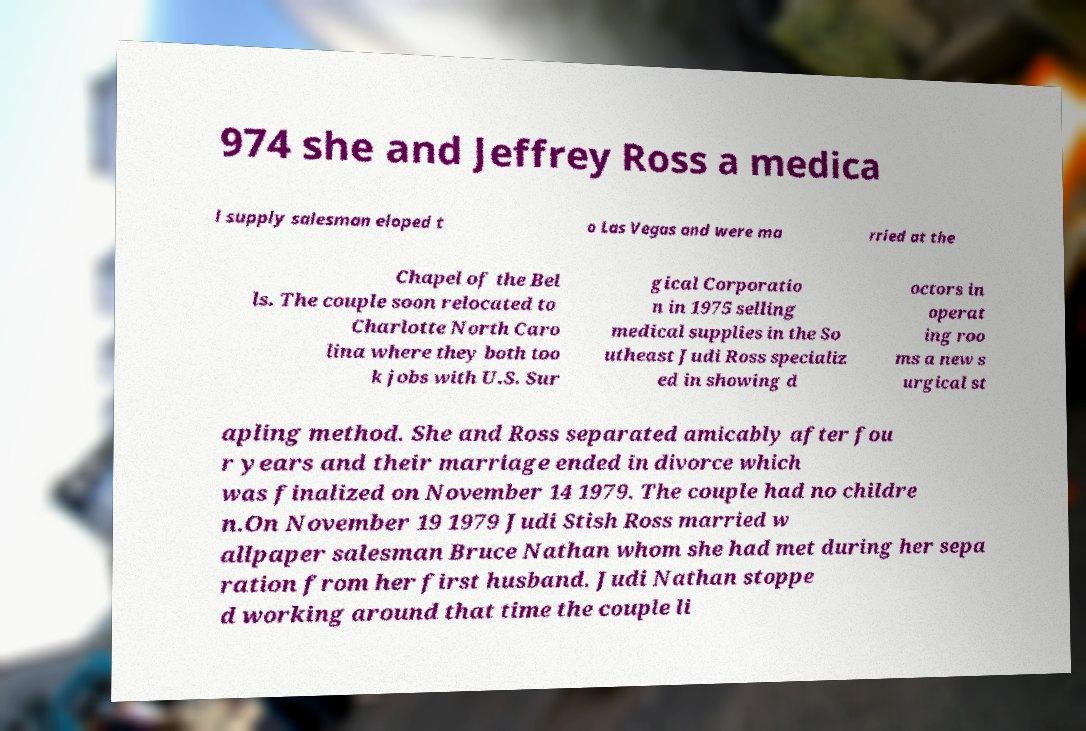Please read and relay the text visible in this image. What does it say? 974 she and Jeffrey Ross a medica l supply salesman eloped t o Las Vegas and were ma rried at the Chapel of the Bel ls. The couple soon relocated to Charlotte North Caro lina where they both too k jobs with U.S. Sur gical Corporatio n in 1975 selling medical supplies in the So utheast Judi Ross specializ ed in showing d octors in operat ing roo ms a new s urgical st apling method. She and Ross separated amicably after fou r years and their marriage ended in divorce which was finalized on November 14 1979. The couple had no childre n.On November 19 1979 Judi Stish Ross married w allpaper salesman Bruce Nathan whom she had met during her sepa ration from her first husband. Judi Nathan stoppe d working around that time the couple li 